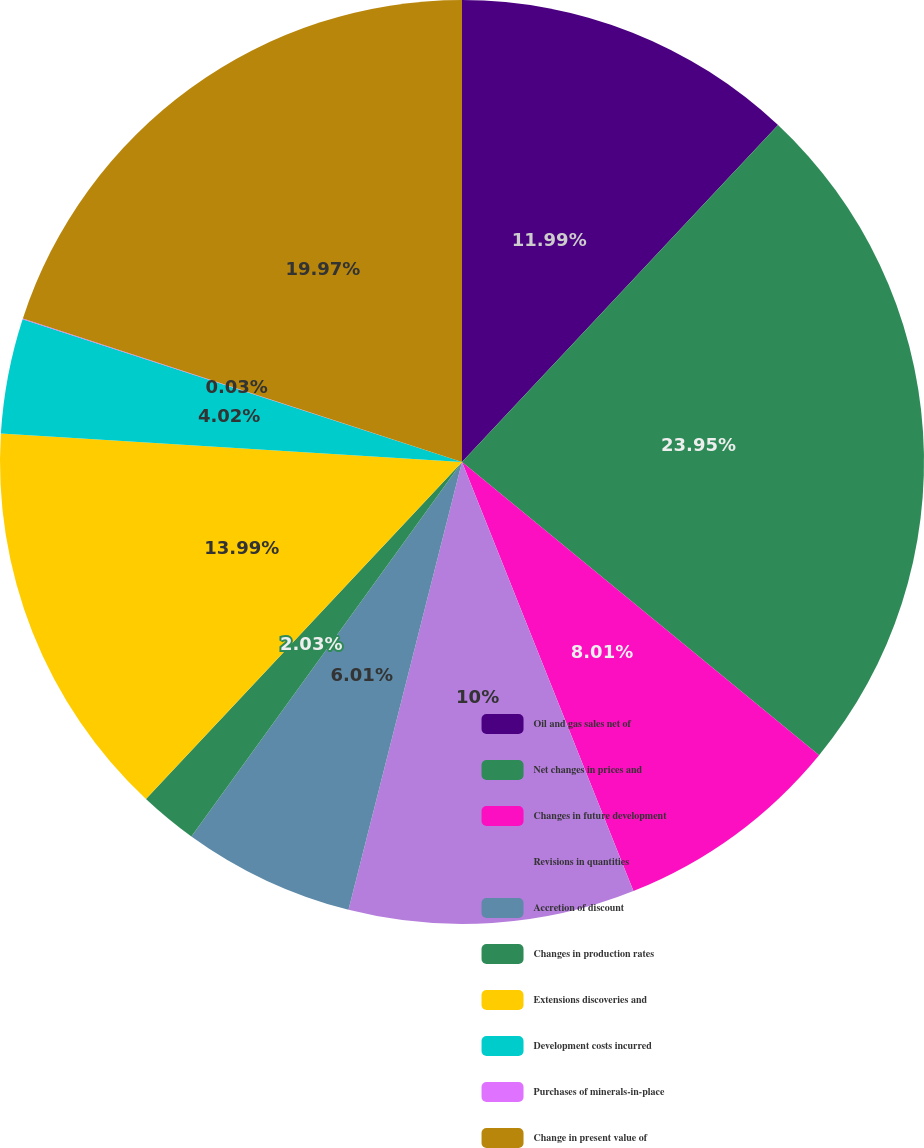Convert chart. <chart><loc_0><loc_0><loc_500><loc_500><pie_chart><fcel>Oil and gas sales net of<fcel>Net changes in prices and<fcel>Changes in future development<fcel>Revisions in quantities<fcel>Accretion of discount<fcel>Changes in production rates<fcel>Extensions discoveries and<fcel>Development costs incurred<fcel>Purchases of minerals-in-place<fcel>Change in present value of<nl><fcel>11.99%<fcel>23.95%<fcel>8.01%<fcel>10.0%<fcel>6.01%<fcel>2.03%<fcel>13.99%<fcel>4.02%<fcel>0.03%<fcel>19.97%<nl></chart> 